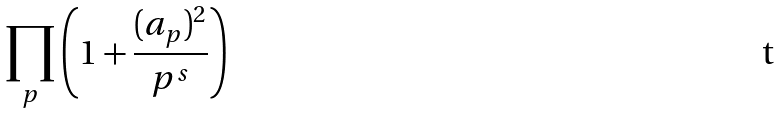Convert formula to latex. <formula><loc_0><loc_0><loc_500><loc_500>\prod _ { p } \left ( 1 + \frac { ( a _ { p } ) ^ { 2 } } { p ^ { s } } \right )</formula> 